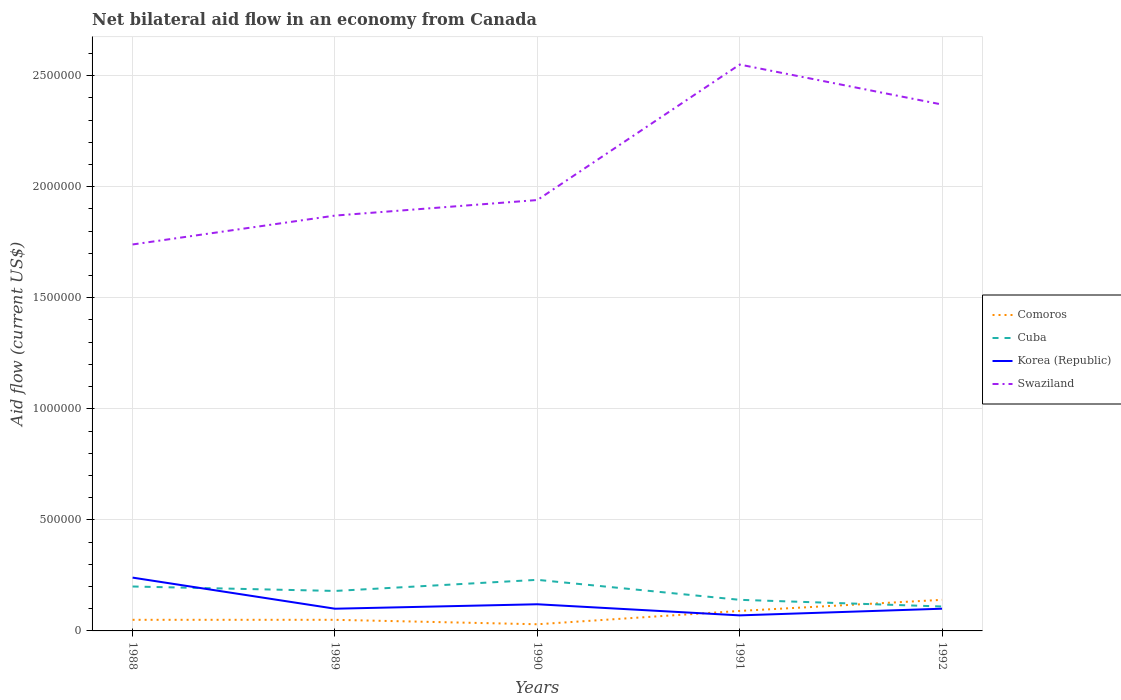Is the number of lines equal to the number of legend labels?
Give a very brief answer. Yes. Across all years, what is the maximum net bilateral aid flow in Comoros?
Provide a succinct answer. 3.00e+04. In which year was the net bilateral aid flow in Cuba maximum?
Offer a very short reply. 1992. What is the difference between the highest and the second highest net bilateral aid flow in Comoros?
Your response must be concise. 1.10e+05. How many years are there in the graph?
Give a very brief answer. 5. What is the difference between two consecutive major ticks on the Y-axis?
Provide a succinct answer. 5.00e+05. Are the values on the major ticks of Y-axis written in scientific E-notation?
Your answer should be compact. No. Does the graph contain any zero values?
Ensure brevity in your answer.  No. Does the graph contain grids?
Provide a succinct answer. Yes. How are the legend labels stacked?
Keep it short and to the point. Vertical. What is the title of the graph?
Your response must be concise. Net bilateral aid flow in an economy from Canada. What is the label or title of the Y-axis?
Your response must be concise. Aid flow (current US$). What is the Aid flow (current US$) in Swaziland in 1988?
Offer a terse response. 1.74e+06. What is the Aid flow (current US$) in Comoros in 1989?
Give a very brief answer. 5.00e+04. What is the Aid flow (current US$) in Swaziland in 1989?
Your answer should be compact. 1.87e+06. What is the Aid flow (current US$) in Comoros in 1990?
Ensure brevity in your answer.  3.00e+04. What is the Aid flow (current US$) in Swaziland in 1990?
Give a very brief answer. 1.94e+06. What is the Aid flow (current US$) in Cuba in 1991?
Your answer should be very brief. 1.40e+05. What is the Aid flow (current US$) of Korea (Republic) in 1991?
Make the answer very short. 7.00e+04. What is the Aid flow (current US$) of Swaziland in 1991?
Your answer should be very brief. 2.55e+06. What is the Aid flow (current US$) of Cuba in 1992?
Offer a terse response. 1.10e+05. What is the Aid flow (current US$) of Korea (Republic) in 1992?
Provide a succinct answer. 1.00e+05. What is the Aid flow (current US$) in Swaziland in 1992?
Provide a succinct answer. 2.37e+06. Across all years, what is the maximum Aid flow (current US$) of Comoros?
Offer a terse response. 1.40e+05. Across all years, what is the maximum Aid flow (current US$) of Swaziland?
Provide a short and direct response. 2.55e+06. Across all years, what is the minimum Aid flow (current US$) in Comoros?
Ensure brevity in your answer.  3.00e+04. Across all years, what is the minimum Aid flow (current US$) of Cuba?
Provide a short and direct response. 1.10e+05. Across all years, what is the minimum Aid flow (current US$) of Swaziland?
Offer a very short reply. 1.74e+06. What is the total Aid flow (current US$) in Comoros in the graph?
Offer a very short reply. 3.60e+05. What is the total Aid flow (current US$) of Cuba in the graph?
Your response must be concise. 8.60e+05. What is the total Aid flow (current US$) in Korea (Republic) in the graph?
Provide a short and direct response. 6.30e+05. What is the total Aid flow (current US$) in Swaziland in the graph?
Give a very brief answer. 1.05e+07. What is the difference between the Aid flow (current US$) in Comoros in 1988 and that in 1989?
Ensure brevity in your answer.  0. What is the difference between the Aid flow (current US$) in Cuba in 1988 and that in 1989?
Provide a succinct answer. 2.00e+04. What is the difference between the Aid flow (current US$) of Korea (Republic) in 1988 and that in 1990?
Your response must be concise. 1.20e+05. What is the difference between the Aid flow (current US$) of Swaziland in 1988 and that in 1990?
Your answer should be compact. -2.00e+05. What is the difference between the Aid flow (current US$) in Korea (Republic) in 1988 and that in 1991?
Give a very brief answer. 1.70e+05. What is the difference between the Aid flow (current US$) in Swaziland in 1988 and that in 1991?
Give a very brief answer. -8.10e+05. What is the difference between the Aid flow (current US$) of Swaziland in 1988 and that in 1992?
Make the answer very short. -6.30e+05. What is the difference between the Aid flow (current US$) in Korea (Republic) in 1989 and that in 1990?
Your response must be concise. -2.00e+04. What is the difference between the Aid flow (current US$) of Swaziland in 1989 and that in 1990?
Provide a succinct answer. -7.00e+04. What is the difference between the Aid flow (current US$) of Comoros in 1989 and that in 1991?
Offer a terse response. -4.00e+04. What is the difference between the Aid flow (current US$) in Swaziland in 1989 and that in 1991?
Make the answer very short. -6.80e+05. What is the difference between the Aid flow (current US$) of Swaziland in 1989 and that in 1992?
Your answer should be compact. -5.00e+05. What is the difference between the Aid flow (current US$) of Comoros in 1990 and that in 1991?
Provide a succinct answer. -6.00e+04. What is the difference between the Aid flow (current US$) of Korea (Republic) in 1990 and that in 1991?
Your answer should be very brief. 5.00e+04. What is the difference between the Aid flow (current US$) of Swaziland in 1990 and that in 1991?
Provide a succinct answer. -6.10e+05. What is the difference between the Aid flow (current US$) of Cuba in 1990 and that in 1992?
Offer a very short reply. 1.20e+05. What is the difference between the Aid flow (current US$) in Korea (Republic) in 1990 and that in 1992?
Your response must be concise. 2.00e+04. What is the difference between the Aid flow (current US$) in Swaziland in 1990 and that in 1992?
Keep it short and to the point. -4.30e+05. What is the difference between the Aid flow (current US$) of Cuba in 1991 and that in 1992?
Your answer should be very brief. 3.00e+04. What is the difference between the Aid flow (current US$) in Comoros in 1988 and the Aid flow (current US$) in Cuba in 1989?
Give a very brief answer. -1.30e+05. What is the difference between the Aid flow (current US$) in Comoros in 1988 and the Aid flow (current US$) in Swaziland in 1989?
Your answer should be compact. -1.82e+06. What is the difference between the Aid flow (current US$) in Cuba in 1988 and the Aid flow (current US$) in Swaziland in 1989?
Your answer should be compact. -1.67e+06. What is the difference between the Aid flow (current US$) in Korea (Republic) in 1988 and the Aid flow (current US$) in Swaziland in 1989?
Give a very brief answer. -1.63e+06. What is the difference between the Aid flow (current US$) in Comoros in 1988 and the Aid flow (current US$) in Swaziland in 1990?
Your answer should be compact. -1.89e+06. What is the difference between the Aid flow (current US$) in Cuba in 1988 and the Aid flow (current US$) in Korea (Republic) in 1990?
Ensure brevity in your answer.  8.00e+04. What is the difference between the Aid flow (current US$) in Cuba in 1988 and the Aid flow (current US$) in Swaziland in 1990?
Your answer should be very brief. -1.74e+06. What is the difference between the Aid flow (current US$) in Korea (Republic) in 1988 and the Aid flow (current US$) in Swaziland in 1990?
Provide a succinct answer. -1.70e+06. What is the difference between the Aid flow (current US$) of Comoros in 1988 and the Aid flow (current US$) of Swaziland in 1991?
Keep it short and to the point. -2.50e+06. What is the difference between the Aid flow (current US$) in Cuba in 1988 and the Aid flow (current US$) in Korea (Republic) in 1991?
Make the answer very short. 1.30e+05. What is the difference between the Aid flow (current US$) in Cuba in 1988 and the Aid flow (current US$) in Swaziland in 1991?
Keep it short and to the point. -2.35e+06. What is the difference between the Aid flow (current US$) in Korea (Republic) in 1988 and the Aid flow (current US$) in Swaziland in 1991?
Offer a very short reply. -2.31e+06. What is the difference between the Aid flow (current US$) in Comoros in 1988 and the Aid flow (current US$) in Cuba in 1992?
Offer a very short reply. -6.00e+04. What is the difference between the Aid flow (current US$) in Comoros in 1988 and the Aid flow (current US$) in Swaziland in 1992?
Give a very brief answer. -2.32e+06. What is the difference between the Aid flow (current US$) in Cuba in 1988 and the Aid flow (current US$) in Korea (Republic) in 1992?
Keep it short and to the point. 1.00e+05. What is the difference between the Aid flow (current US$) in Cuba in 1988 and the Aid flow (current US$) in Swaziland in 1992?
Give a very brief answer. -2.17e+06. What is the difference between the Aid flow (current US$) of Korea (Republic) in 1988 and the Aid flow (current US$) of Swaziland in 1992?
Offer a very short reply. -2.13e+06. What is the difference between the Aid flow (current US$) of Comoros in 1989 and the Aid flow (current US$) of Cuba in 1990?
Offer a terse response. -1.80e+05. What is the difference between the Aid flow (current US$) in Comoros in 1989 and the Aid flow (current US$) in Swaziland in 1990?
Ensure brevity in your answer.  -1.89e+06. What is the difference between the Aid flow (current US$) of Cuba in 1989 and the Aid flow (current US$) of Swaziland in 1990?
Offer a very short reply. -1.76e+06. What is the difference between the Aid flow (current US$) of Korea (Republic) in 1989 and the Aid flow (current US$) of Swaziland in 1990?
Your response must be concise. -1.84e+06. What is the difference between the Aid flow (current US$) of Comoros in 1989 and the Aid flow (current US$) of Cuba in 1991?
Give a very brief answer. -9.00e+04. What is the difference between the Aid flow (current US$) of Comoros in 1989 and the Aid flow (current US$) of Swaziland in 1991?
Give a very brief answer. -2.50e+06. What is the difference between the Aid flow (current US$) of Cuba in 1989 and the Aid flow (current US$) of Korea (Republic) in 1991?
Make the answer very short. 1.10e+05. What is the difference between the Aid flow (current US$) of Cuba in 1989 and the Aid flow (current US$) of Swaziland in 1991?
Make the answer very short. -2.37e+06. What is the difference between the Aid flow (current US$) in Korea (Republic) in 1989 and the Aid flow (current US$) in Swaziland in 1991?
Ensure brevity in your answer.  -2.45e+06. What is the difference between the Aid flow (current US$) in Comoros in 1989 and the Aid flow (current US$) in Korea (Republic) in 1992?
Ensure brevity in your answer.  -5.00e+04. What is the difference between the Aid flow (current US$) in Comoros in 1989 and the Aid flow (current US$) in Swaziland in 1992?
Provide a short and direct response. -2.32e+06. What is the difference between the Aid flow (current US$) of Cuba in 1989 and the Aid flow (current US$) of Korea (Republic) in 1992?
Keep it short and to the point. 8.00e+04. What is the difference between the Aid flow (current US$) in Cuba in 1989 and the Aid flow (current US$) in Swaziland in 1992?
Your answer should be very brief. -2.19e+06. What is the difference between the Aid flow (current US$) in Korea (Republic) in 1989 and the Aid flow (current US$) in Swaziland in 1992?
Your response must be concise. -2.27e+06. What is the difference between the Aid flow (current US$) in Comoros in 1990 and the Aid flow (current US$) in Korea (Republic) in 1991?
Provide a succinct answer. -4.00e+04. What is the difference between the Aid flow (current US$) of Comoros in 1990 and the Aid flow (current US$) of Swaziland in 1991?
Your response must be concise. -2.52e+06. What is the difference between the Aid flow (current US$) in Cuba in 1990 and the Aid flow (current US$) in Korea (Republic) in 1991?
Your answer should be compact. 1.60e+05. What is the difference between the Aid flow (current US$) in Cuba in 1990 and the Aid flow (current US$) in Swaziland in 1991?
Offer a terse response. -2.32e+06. What is the difference between the Aid flow (current US$) in Korea (Republic) in 1990 and the Aid flow (current US$) in Swaziland in 1991?
Ensure brevity in your answer.  -2.43e+06. What is the difference between the Aid flow (current US$) of Comoros in 1990 and the Aid flow (current US$) of Cuba in 1992?
Keep it short and to the point. -8.00e+04. What is the difference between the Aid flow (current US$) of Comoros in 1990 and the Aid flow (current US$) of Swaziland in 1992?
Your answer should be compact. -2.34e+06. What is the difference between the Aid flow (current US$) in Cuba in 1990 and the Aid flow (current US$) in Korea (Republic) in 1992?
Your answer should be very brief. 1.30e+05. What is the difference between the Aid flow (current US$) in Cuba in 1990 and the Aid flow (current US$) in Swaziland in 1992?
Provide a succinct answer. -2.14e+06. What is the difference between the Aid flow (current US$) in Korea (Republic) in 1990 and the Aid flow (current US$) in Swaziland in 1992?
Offer a terse response. -2.25e+06. What is the difference between the Aid flow (current US$) of Comoros in 1991 and the Aid flow (current US$) of Korea (Republic) in 1992?
Ensure brevity in your answer.  -10000. What is the difference between the Aid flow (current US$) of Comoros in 1991 and the Aid flow (current US$) of Swaziland in 1992?
Give a very brief answer. -2.28e+06. What is the difference between the Aid flow (current US$) in Cuba in 1991 and the Aid flow (current US$) in Korea (Republic) in 1992?
Your answer should be compact. 4.00e+04. What is the difference between the Aid flow (current US$) of Cuba in 1991 and the Aid flow (current US$) of Swaziland in 1992?
Provide a short and direct response. -2.23e+06. What is the difference between the Aid flow (current US$) in Korea (Republic) in 1991 and the Aid flow (current US$) in Swaziland in 1992?
Make the answer very short. -2.30e+06. What is the average Aid flow (current US$) of Comoros per year?
Offer a terse response. 7.20e+04. What is the average Aid flow (current US$) in Cuba per year?
Your answer should be compact. 1.72e+05. What is the average Aid flow (current US$) in Korea (Republic) per year?
Provide a succinct answer. 1.26e+05. What is the average Aid flow (current US$) of Swaziland per year?
Give a very brief answer. 2.09e+06. In the year 1988, what is the difference between the Aid flow (current US$) in Comoros and Aid flow (current US$) in Swaziland?
Your response must be concise. -1.69e+06. In the year 1988, what is the difference between the Aid flow (current US$) of Cuba and Aid flow (current US$) of Swaziland?
Provide a short and direct response. -1.54e+06. In the year 1988, what is the difference between the Aid flow (current US$) in Korea (Republic) and Aid flow (current US$) in Swaziland?
Provide a short and direct response. -1.50e+06. In the year 1989, what is the difference between the Aid flow (current US$) in Comoros and Aid flow (current US$) in Swaziland?
Give a very brief answer. -1.82e+06. In the year 1989, what is the difference between the Aid flow (current US$) in Cuba and Aid flow (current US$) in Swaziland?
Ensure brevity in your answer.  -1.69e+06. In the year 1989, what is the difference between the Aid flow (current US$) of Korea (Republic) and Aid flow (current US$) of Swaziland?
Give a very brief answer. -1.77e+06. In the year 1990, what is the difference between the Aid flow (current US$) in Comoros and Aid flow (current US$) in Cuba?
Provide a succinct answer. -2.00e+05. In the year 1990, what is the difference between the Aid flow (current US$) in Comoros and Aid flow (current US$) in Korea (Republic)?
Your answer should be very brief. -9.00e+04. In the year 1990, what is the difference between the Aid flow (current US$) of Comoros and Aid flow (current US$) of Swaziland?
Make the answer very short. -1.91e+06. In the year 1990, what is the difference between the Aid flow (current US$) in Cuba and Aid flow (current US$) in Korea (Republic)?
Offer a terse response. 1.10e+05. In the year 1990, what is the difference between the Aid flow (current US$) of Cuba and Aid flow (current US$) of Swaziland?
Your answer should be very brief. -1.71e+06. In the year 1990, what is the difference between the Aid flow (current US$) of Korea (Republic) and Aid flow (current US$) of Swaziland?
Ensure brevity in your answer.  -1.82e+06. In the year 1991, what is the difference between the Aid flow (current US$) in Comoros and Aid flow (current US$) in Cuba?
Keep it short and to the point. -5.00e+04. In the year 1991, what is the difference between the Aid flow (current US$) in Comoros and Aid flow (current US$) in Korea (Republic)?
Provide a short and direct response. 2.00e+04. In the year 1991, what is the difference between the Aid flow (current US$) of Comoros and Aid flow (current US$) of Swaziland?
Keep it short and to the point. -2.46e+06. In the year 1991, what is the difference between the Aid flow (current US$) in Cuba and Aid flow (current US$) in Swaziland?
Ensure brevity in your answer.  -2.41e+06. In the year 1991, what is the difference between the Aid flow (current US$) in Korea (Republic) and Aid flow (current US$) in Swaziland?
Your answer should be compact. -2.48e+06. In the year 1992, what is the difference between the Aid flow (current US$) of Comoros and Aid flow (current US$) of Korea (Republic)?
Make the answer very short. 4.00e+04. In the year 1992, what is the difference between the Aid flow (current US$) in Comoros and Aid flow (current US$) in Swaziland?
Your response must be concise. -2.23e+06. In the year 1992, what is the difference between the Aid flow (current US$) in Cuba and Aid flow (current US$) in Korea (Republic)?
Offer a very short reply. 10000. In the year 1992, what is the difference between the Aid flow (current US$) of Cuba and Aid flow (current US$) of Swaziland?
Make the answer very short. -2.26e+06. In the year 1992, what is the difference between the Aid flow (current US$) of Korea (Republic) and Aid flow (current US$) of Swaziland?
Ensure brevity in your answer.  -2.27e+06. What is the ratio of the Aid flow (current US$) of Cuba in 1988 to that in 1989?
Your answer should be compact. 1.11. What is the ratio of the Aid flow (current US$) in Korea (Republic) in 1988 to that in 1989?
Give a very brief answer. 2.4. What is the ratio of the Aid flow (current US$) of Swaziland in 1988 to that in 1989?
Provide a short and direct response. 0.93. What is the ratio of the Aid flow (current US$) of Cuba in 1988 to that in 1990?
Your response must be concise. 0.87. What is the ratio of the Aid flow (current US$) of Korea (Republic) in 1988 to that in 1990?
Ensure brevity in your answer.  2. What is the ratio of the Aid flow (current US$) of Swaziland in 1988 to that in 1990?
Provide a short and direct response. 0.9. What is the ratio of the Aid flow (current US$) in Comoros in 1988 to that in 1991?
Provide a short and direct response. 0.56. What is the ratio of the Aid flow (current US$) in Cuba in 1988 to that in 1991?
Make the answer very short. 1.43. What is the ratio of the Aid flow (current US$) in Korea (Republic) in 1988 to that in 1991?
Provide a succinct answer. 3.43. What is the ratio of the Aid flow (current US$) of Swaziland in 1988 to that in 1991?
Your answer should be very brief. 0.68. What is the ratio of the Aid flow (current US$) of Comoros in 1988 to that in 1992?
Give a very brief answer. 0.36. What is the ratio of the Aid flow (current US$) in Cuba in 1988 to that in 1992?
Your response must be concise. 1.82. What is the ratio of the Aid flow (current US$) in Swaziland in 1988 to that in 1992?
Keep it short and to the point. 0.73. What is the ratio of the Aid flow (current US$) of Cuba in 1989 to that in 1990?
Provide a short and direct response. 0.78. What is the ratio of the Aid flow (current US$) of Korea (Republic) in 1989 to that in 1990?
Ensure brevity in your answer.  0.83. What is the ratio of the Aid flow (current US$) of Swaziland in 1989 to that in 1990?
Make the answer very short. 0.96. What is the ratio of the Aid flow (current US$) in Comoros in 1989 to that in 1991?
Ensure brevity in your answer.  0.56. What is the ratio of the Aid flow (current US$) of Korea (Republic) in 1989 to that in 1991?
Your answer should be compact. 1.43. What is the ratio of the Aid flow (current US$) of Swaziland in 1989 to that in 1991?
Keep it short and to the point. 0.73. What is the ratio of the Aid flow (current US$) in Comoros in 1989 to that in 1992?
Offer a very short reply. 0.36. What is the ratio of the Aid flow (current US$) in Cuba in 1989 to that in 1992?
Keep it short and to the point. 1.64. What is the ratio of the Aid flow (current US$) in Korea (Republic) in 1989 to that in 1992?
Ensure brevity in your answer.  1. What is the ratio of the Aid flow (current US$) in Swaziland in 1989 to that in 1992?
Your answer should be very brief. 0.79. What is the ratio of the Aid flow (current US$) of Comoros in 1990 to that in 1991?
Provide a short and direct response. 0.33. What is the ratio of the Aid flow (current US$) of Cuba in 1990 to that in 1991?
Offer a terse response. 1.64. What is the ratio of the Aid flow (current US$) in Korea (Republic) in 1990 to that in 1991?
Offer a very short reply. 1.71. What is the ratio of the Aid flow (current US$) of Swaziland in 1990 to that in 1991?
Your answer should be compact. 0.76. What is the ratio of the Aid flow (current US$) of Comoros in 1990 to that in 1992?
Provide a short and direct response. 0.21. What is the ratio of the Aid flow (current US$) in Cuba in 1990 to that in 1992?
Keep it short and to the point. 2.09. What is the ratio of the Aid flow (current US$) of Korea (Republic) in 1990 to that in 1992?
Provide a succinct answer. 1.2. What is the ratio of the Aid flow (current US$) in Swaziland in 1990 to that in 1992?
Give a very brief answer. 0.82. What is the ratio of the Aid flow (current US$) of Comoros in 1991 to that in 1992?
Offer a very short reply. 0.64. What is the ratio of the Aid flow (current US$) in Cuba in 1991 to that in 1992?
Provide a succinct answer. 1.27. What is the ratio of the Aid flow (current US$) of Korea (Republic) in 1991 to that in 1992?
Your response must be concise. 0.7. What is the ratio of the Aid flow (current US$) of Swaziland in 1991 to that in 1992?
Offer a very short reply. 1.08. What is the difference between the highest and the second highest Aid flow (current US$) in Comoros?
Make the answer very short. 5.00e+04. What is the difference between the highest and the second highest Aid flow (current US$) of Cuba?
Your response must be concise. 3.00e+04. What is the difference between the highest and the second highest Aid flow (current US$) of Swaziland?
Give a very brief answer. 1.80e+05. What is the difference between the highest and the lowest Aid flow (current US$) of Cuba?
Keep it short and to the point. 1.20e+05. What is the difference between the highest and the lowest Aid flow (current US$) of Swaziland?
Your response must be concise. 8.10e+05. 